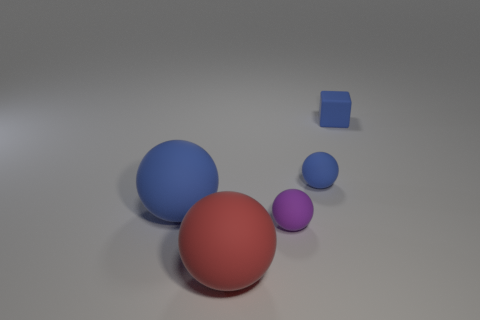What number of tiny purple matte objects are there? 1 